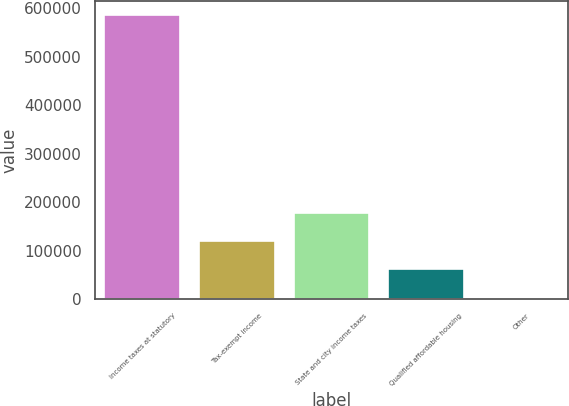Convert chart. <chart><loc_0><loc_0><loc_500><loc_500><bar_chart><fcel>Income taxes at statutory<fcel>Tax-exempt income<fcel>State and city income taxes<fcel>Qualified affordable housing<fcel>Other<nl><fcel>586142<fcel>120193<fcel>178437<fcel>61949.6<fcel>3706<nl></chart> 